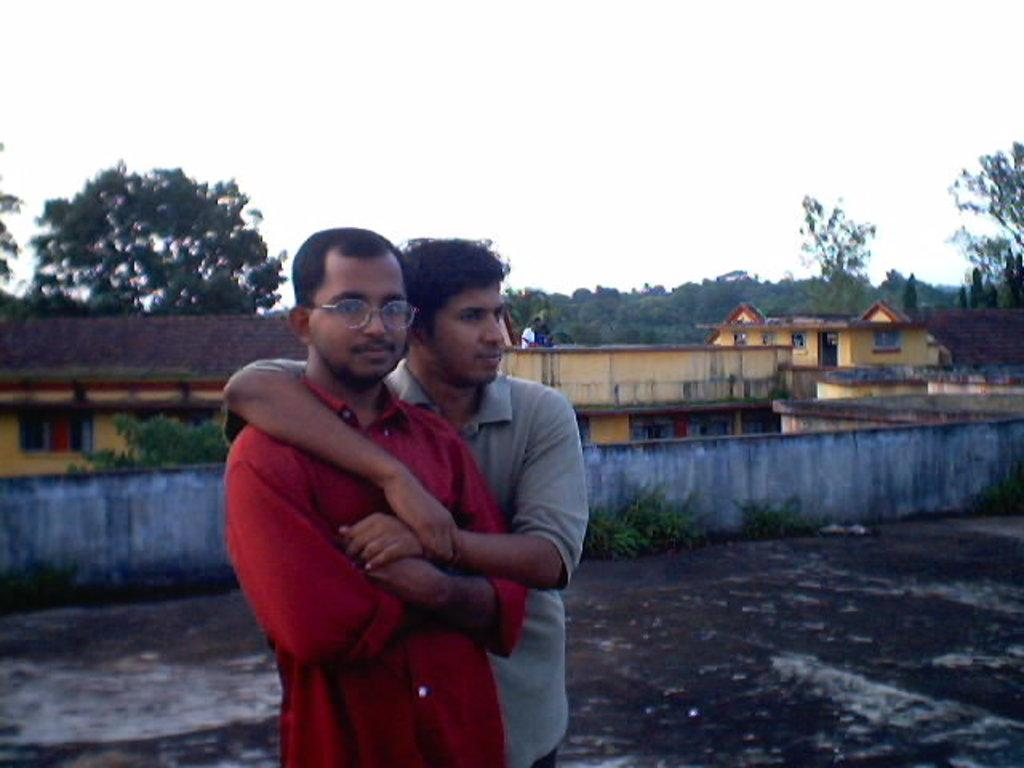How many men are in the image? There are two men standing in the image. What can be seen in the background of the image? There is a wall, a person, buildings, plants, a group of trees, and the sky visible in the background of the image. What is the condition of the sky in the image? The sky appears cloudy in the image. What type of bell can be heard ringing in the image? There is no bell present or audible in the image. What kind of art is displayed on the wall in the image? There is no art displayed on the wall in the image; only a wall is visible in the background. Can you see any cows in the image? There are no cows present in the image. 